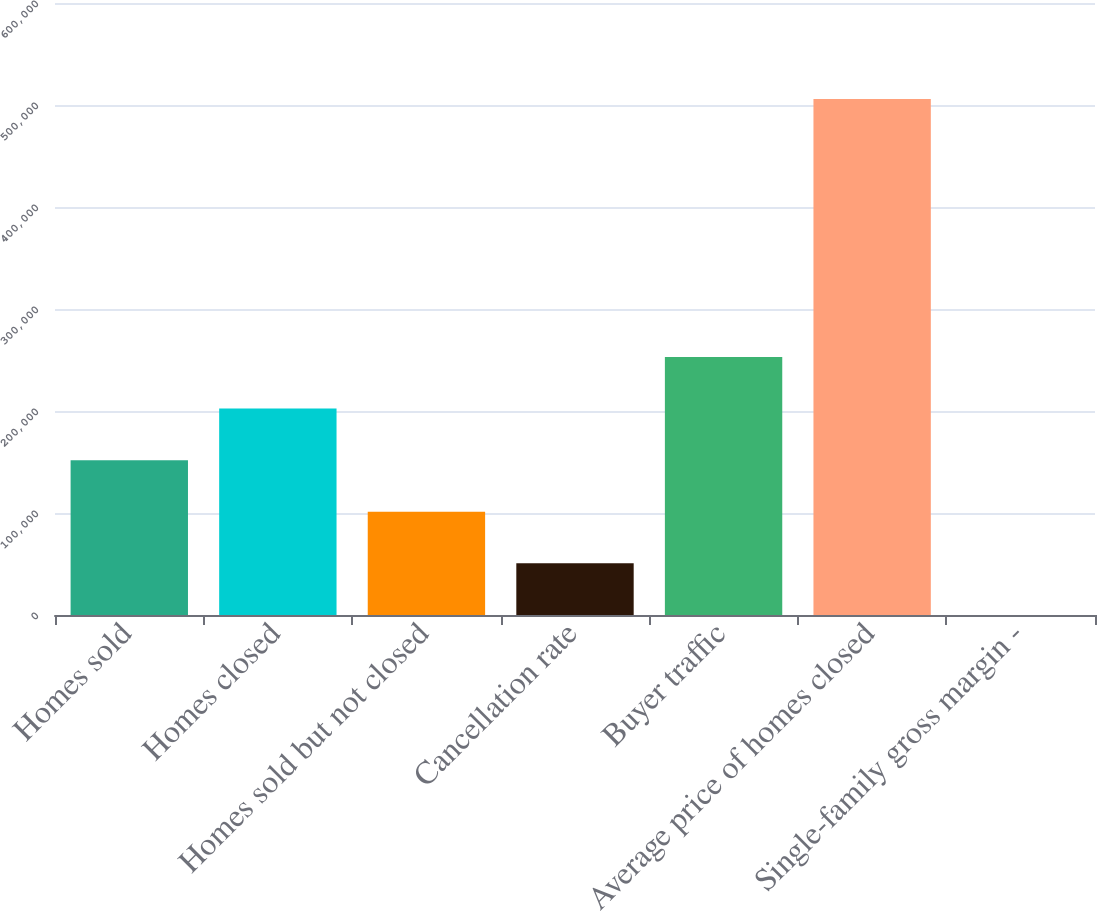Convert chart to OTSL. <chart><loc_0><loc_0><loc_500><loc_500><bar_chart><fcel>Homes sold<fcel>Homes closed<fcel>Homes sold but not closed<fcel>Cancellation rate<fcel>Buyer traffic<fcel>Average price of homes closed<fcel>Single-family gross margin -<nl><fcel>151820<fcel>202417<fcel>101222<fcel>50625.2<fcel>253014<fcel>506000<fcel>28<nl></chart> 